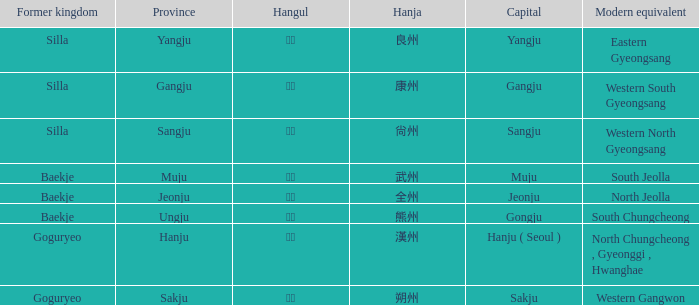Which capital is associated with the hanja 尙州? Sangju. 